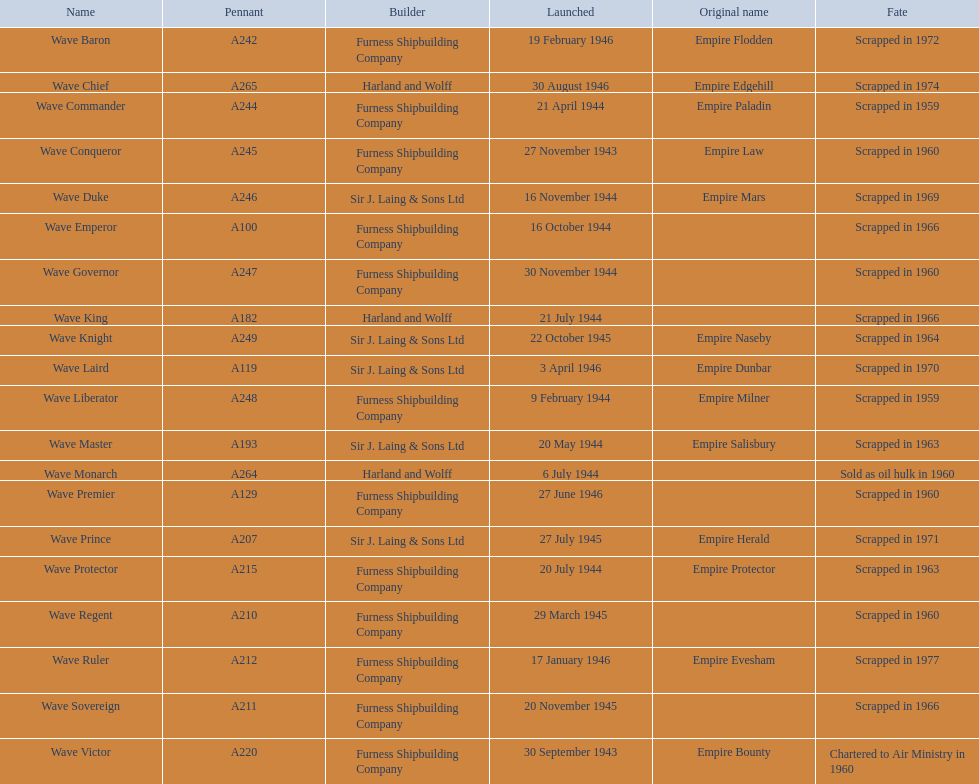What is a building company with the word "and" in its name? Harland and Wolff. 